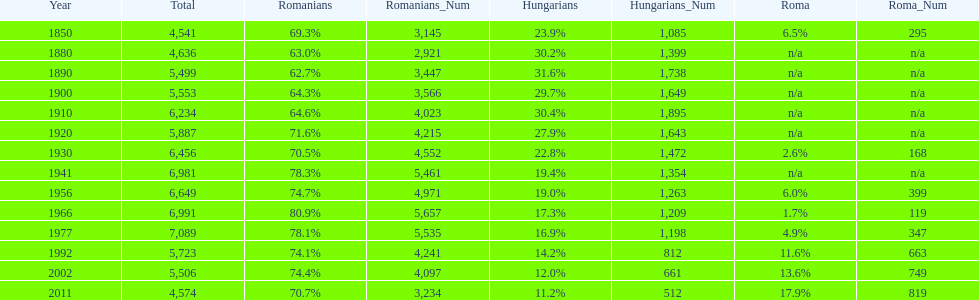In what year was there the largest percentage of hungarians? 1890. 